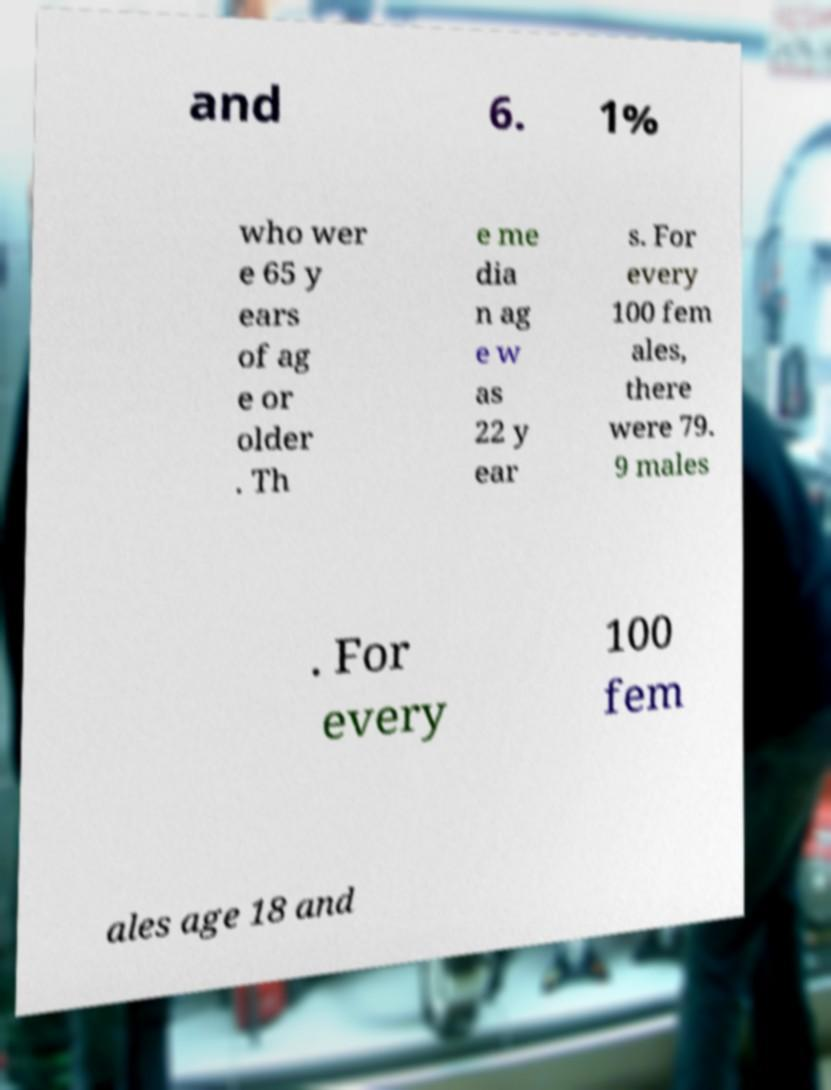Could you extract and type out the text from this image? and 6. 1% who wer e 65 y ears of ag e or older . Th e me dia n ag e w as 22 y ear s. For every 100 fem ales, there were 79. 9 males . For every 100 fem ales age 18 and 